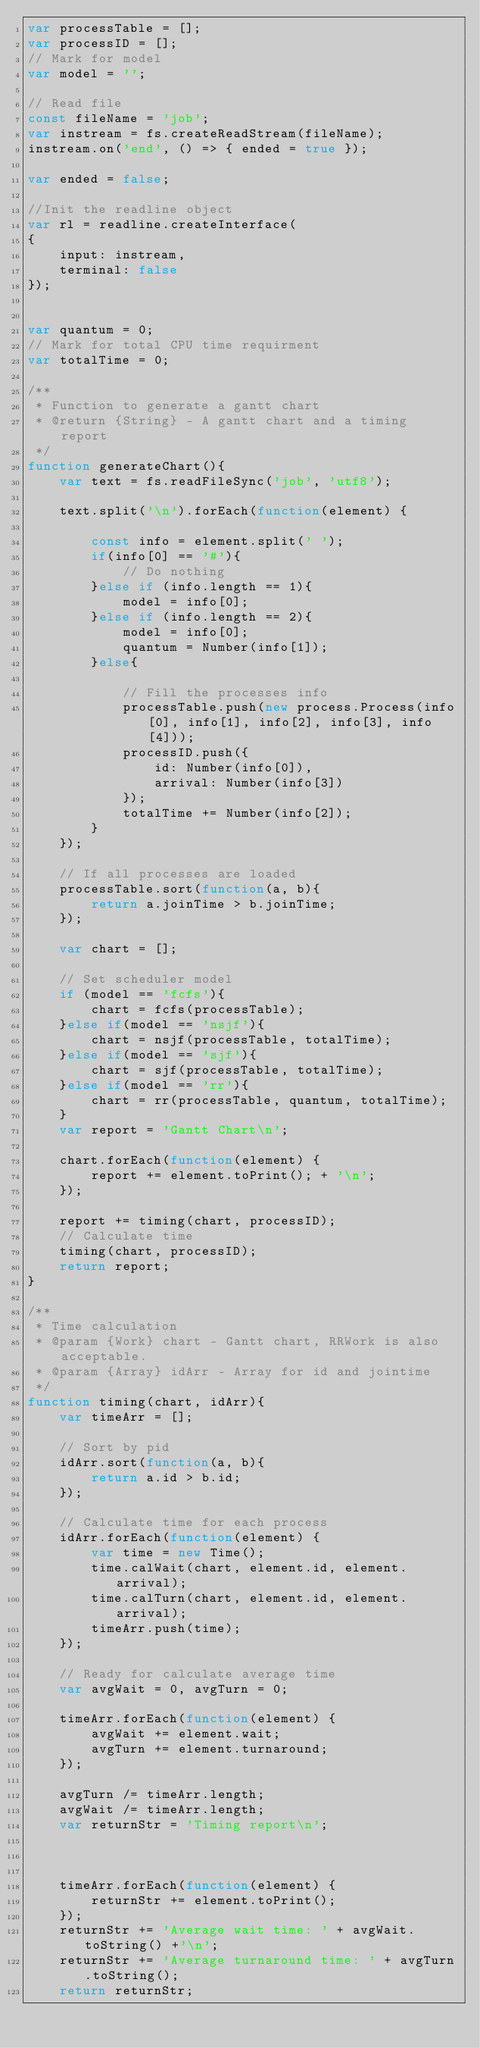<code> <loc_0><loc_0><loc_500><loc_500><_JavaScript_>var processTable = [];
var processID = [];
// Mark for model
var model = '';

// Read file
const fileName = 'job';
var instream = fs.createReadStream(fileName);
instream.on('end', () => { ended = true });

var ended = false;

//Init the readline object
var rl = readline.createInterface(
{
    input: instream,
    terminal: false
});


var quantum = 0;
// Mark for total CPU time requirment
var totalTime = 0;

/**
 * Function to generate a gantt chart
 * @return {String} - A gantt chart and a timing report
 */
function generateChart(){
    var text = fs.readFileSync('job', 'utf8');

    text.split('\n').forEach(function(element) {
    
        const info = element.split(' ');
        if(info[0] == '#'){
            // Do nothing
        }else if (info.length == 1){
            model = info[0];
        }else if (info.length == 2){
            model = info[0];
            quantum = Number(info[1]);
        }else{

            // Fill the processes info
            processTable.push(new process.Process(info[0], info[1], info[2], info[3], info[4]));
            processID.push({
                id: Number(info[0]),
                arrival: Number(info[3])
            });
            totalTime += Number(info[2]);
        }
    });

    // If all processes are loaded
    processTable.sort(function(a, b){
        return a.joinTime > b.joinTime;
    });

    var chart = [];

    // Set scheduler model
    if (model == 'fcfs'){
        chart = fcfs(processTable);
    }else if(model == 'nsjf'){
        chart = nsjf(processTable, totalTime);
    }else if(model == 'sjf'){
        chart = sjf(processTable, totalTime);
    }else if(model == 'rr'){
        chart = rr(processTable, quantum, totalTime);
    }
    var report = 'Gantt Chart\n';

    chart.forEach(function(element) {
        report += element.toPrint(); + '\n';
    });
    
    report += timing(chart, processID);
    // Calculate time
    timing(chart, processID);
    return report;
}

/**
 * Time calculation
 * @param {Work} chart - Gantt chart, RRWork is also acceptable.
 * @param {Array} idArr - Array for id and jointime
 */
function timing(chart, idArr){
    var timeArr = [];

    // Sort by pid
    idArr.sort(function(a, b){
        return a.id > b.id;
    });

    // Calculate time for each process
    idArr.forEach(function(element) {
        var time = new Time();
        time.calWait(chart, element.id, element.arrival);
        time.calTurn(chart, element.id, element.arrival);
        timeArr.push(time);
    });

    // Ready for calculate average time
    var avgWait = 0, avgTurn = 0;

    timeArr.forEach(function(element) {
        avgWait += element.wait;
        avgTurn += element.turnaround;
    });

    avgTurn /= timeArr.length;
    avgWait /= timeArr.length;
    var returnStr = 'Timing report\n';

    

    timeArr.forEach(function(element) {
        returnStr += element.toPrint();
    });
    returnStr += 'Average wait time: ' + avgWait.toString() +'\n';
    returnStr += 'Average turnaround time: ' + avgTurn.toString();
    return returnStr;</code> 